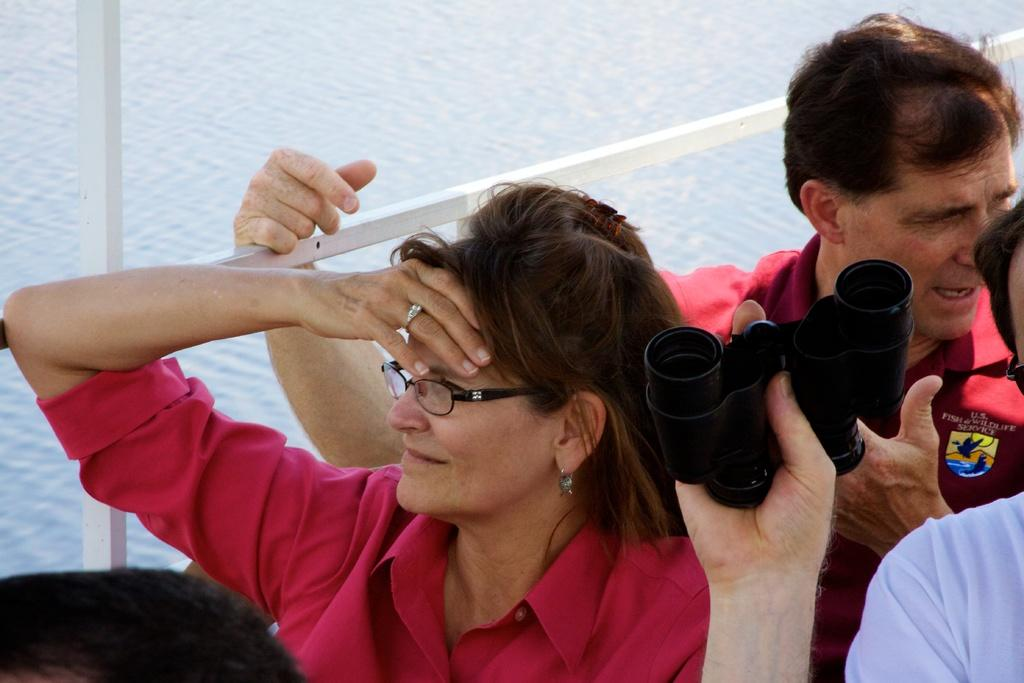How many people are in the image? There is a group of people in the image. What is one person in the group holding? One person is holding binoculars. What can be seen in the background of the image? There are poles and water visible in the background of the image. How many forms can be seen in the image? There are no forms present in the image; it is a group of people, poles, and water. How long does it take for the bit to be completed in the image? There is no bit or any activity related to it in the image. 